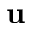Convert formula to latex. <formula><loc_0><loc_0><loc_500><loc_500>u</formula> 